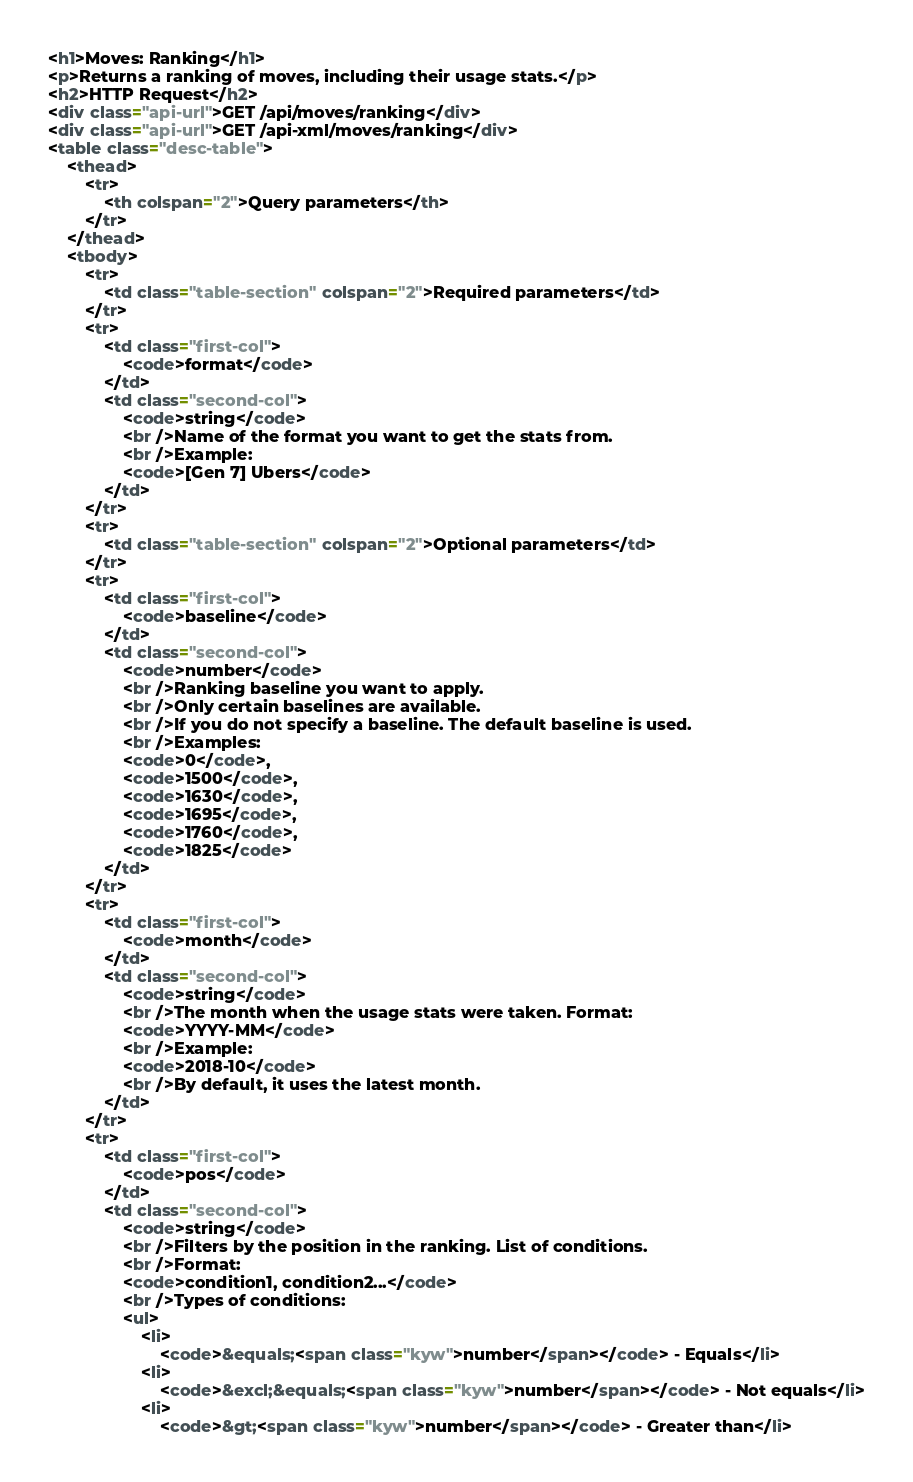Convert code to text. <code><loc_0><loc_0><loc_500><loc_500><_HTML_><h1>Moves: Ranking</h1>
<p>Returns a ranking of moves, including their usage stats.</p>
<h2>HTTP Request</h2>
<div class="api-url">GET /api/moves/ranking</div>
<div class="api-url">GET /api-xml/moves/ranking</div>
<table class="desc-table">
    <thead>
        <tr>
            <th colspan="2">Query parameters</th>
        </tr>
    </thead>
    <tbody>
        <tr>
            <td class="table-section" colspan="2">Required parameters</td>
        </tr>
        <tr>
            <td class="first-col">
                <code>format</code>
            </td>
            <td class="second-col">
                <code>string</code>
                <br />Name of the format you want to get the stats from.
                <br />Example:
                <code>[Gen 7] Ubers</code>
            </td>
        </tr>
        <tr>
            <td class="table-section" colspan="2">Optional parameters</td>
        </tr>
        <tr>
            <td class="first-col">
                <code>baseline</code>
            </td>
            <td class="second-col">
                <code>number</code>
                <br />Ranking baseline you want to apply.
                <br />Only certain baselines are available.
                <br />If you do not specify a baseline. The default baseline is used.
                <br />Examples:
                <code>0</code>,
                <code>1500</code>,
                <code>1630</code>,
                <code>1695</code>,
                <code>1760</code>,
                <code>1825</code>
            </td>
        </tr>
        <tr>
            <td class="first-col">
                <code>month</code>
            </td>
            <td class="second-col">
                <code>string</code>
                <br />The month when the usage stats were taken. Format:
                <code>YYYY-MM</code>
                <br />Example:
                <code>2018-10</code>
                <br />By default, it uses the latest month.
            </td>
        </tr>
        <tr>
            <td class="first-col">
                <code>pos</code>
            </td>
            <td class="second-col">
                <code>string</code>
                <br />Filters by the position in the ranking. List of conditions.
                <br />Format:
                <code>condition1, condition2...</code>
                <br />Types of conditions:
                <ul>
                    <li>
                        <code>&equals;<span class="kyw">number</span></code> - Equals</li>
                    <li>
                        <code>&excl;&equals;<span class="kyw">number</span></code> - Not equals</li>
                    <li>
                        <code>&gt;<span class="kyw">number</span></code> - Greater than</li></code> 